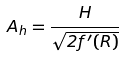Convert formula to latex. <formula><loc_0><loc_0><loc_500><loc_500>A _ { h } = \frac { H } { \sqrt { 2 f ^ { \prime } ( R ) } }</formula> 